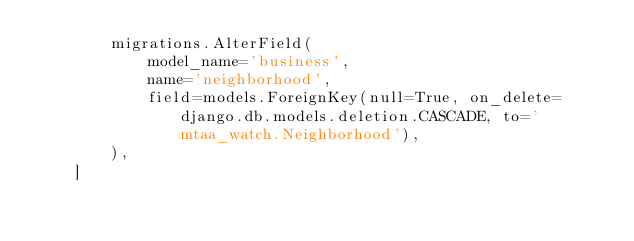Convert code to text. <code><loc_0><loc_0><loc_500><loc_500><_Python_>        migrations.AlterField(
            model_name='business',
            name='neighborhood',
            field=models.ForeignKey(null=True, on_delete=django.db.models.deletion.CASCADE, to='mtaa_watch.Neighborhood'),
        ),
    ]
</code> 